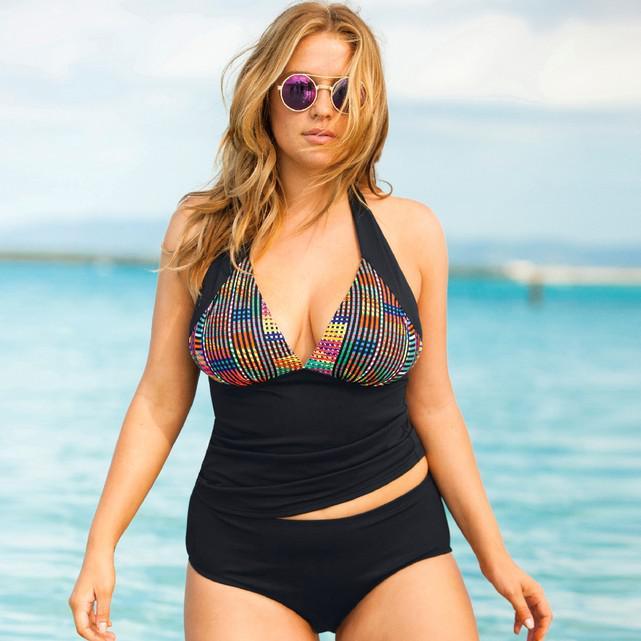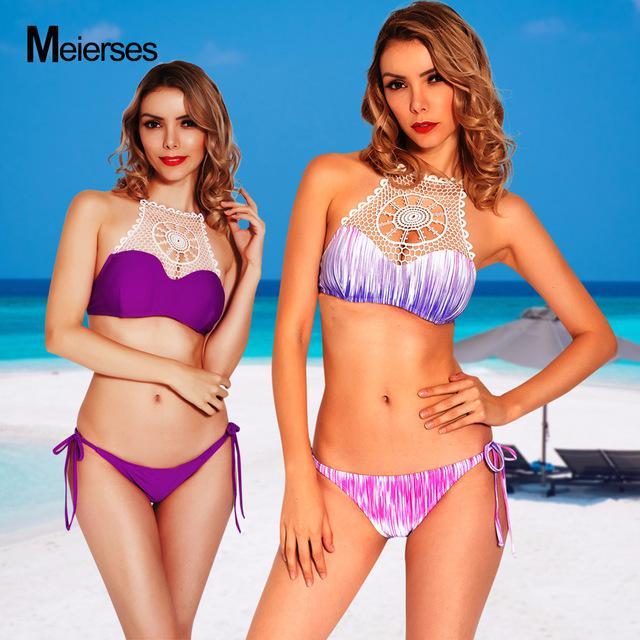The first image is the image on the left, the second image is the image on the right. Given the left and right images, does the statement "The right image shows exactly two models wearing bikinis with tops that extend over the chest and taper up to the neck." hold true? Answer yes or no. Yes. The first image is the image on the left, the second image is the image on the right. Assess this claim about the two images: "Both images contain the same number of women.". Correct or not? Answer yes or no. No. 